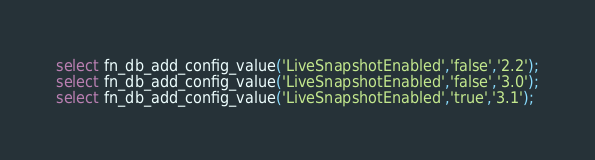Convert code to text. <code><loc_0><loc_0><loc_500><loc_500><_SQL_>select fn_db_add_config_value('LiveSnapshotEnabled','false','2.2');
select fn_db_add_config_value('LiveSnapshotEnabled','false','3.0');
select fn_db_add_config_value('LiveSnapshotEnabled','true','3.1');
</code> 